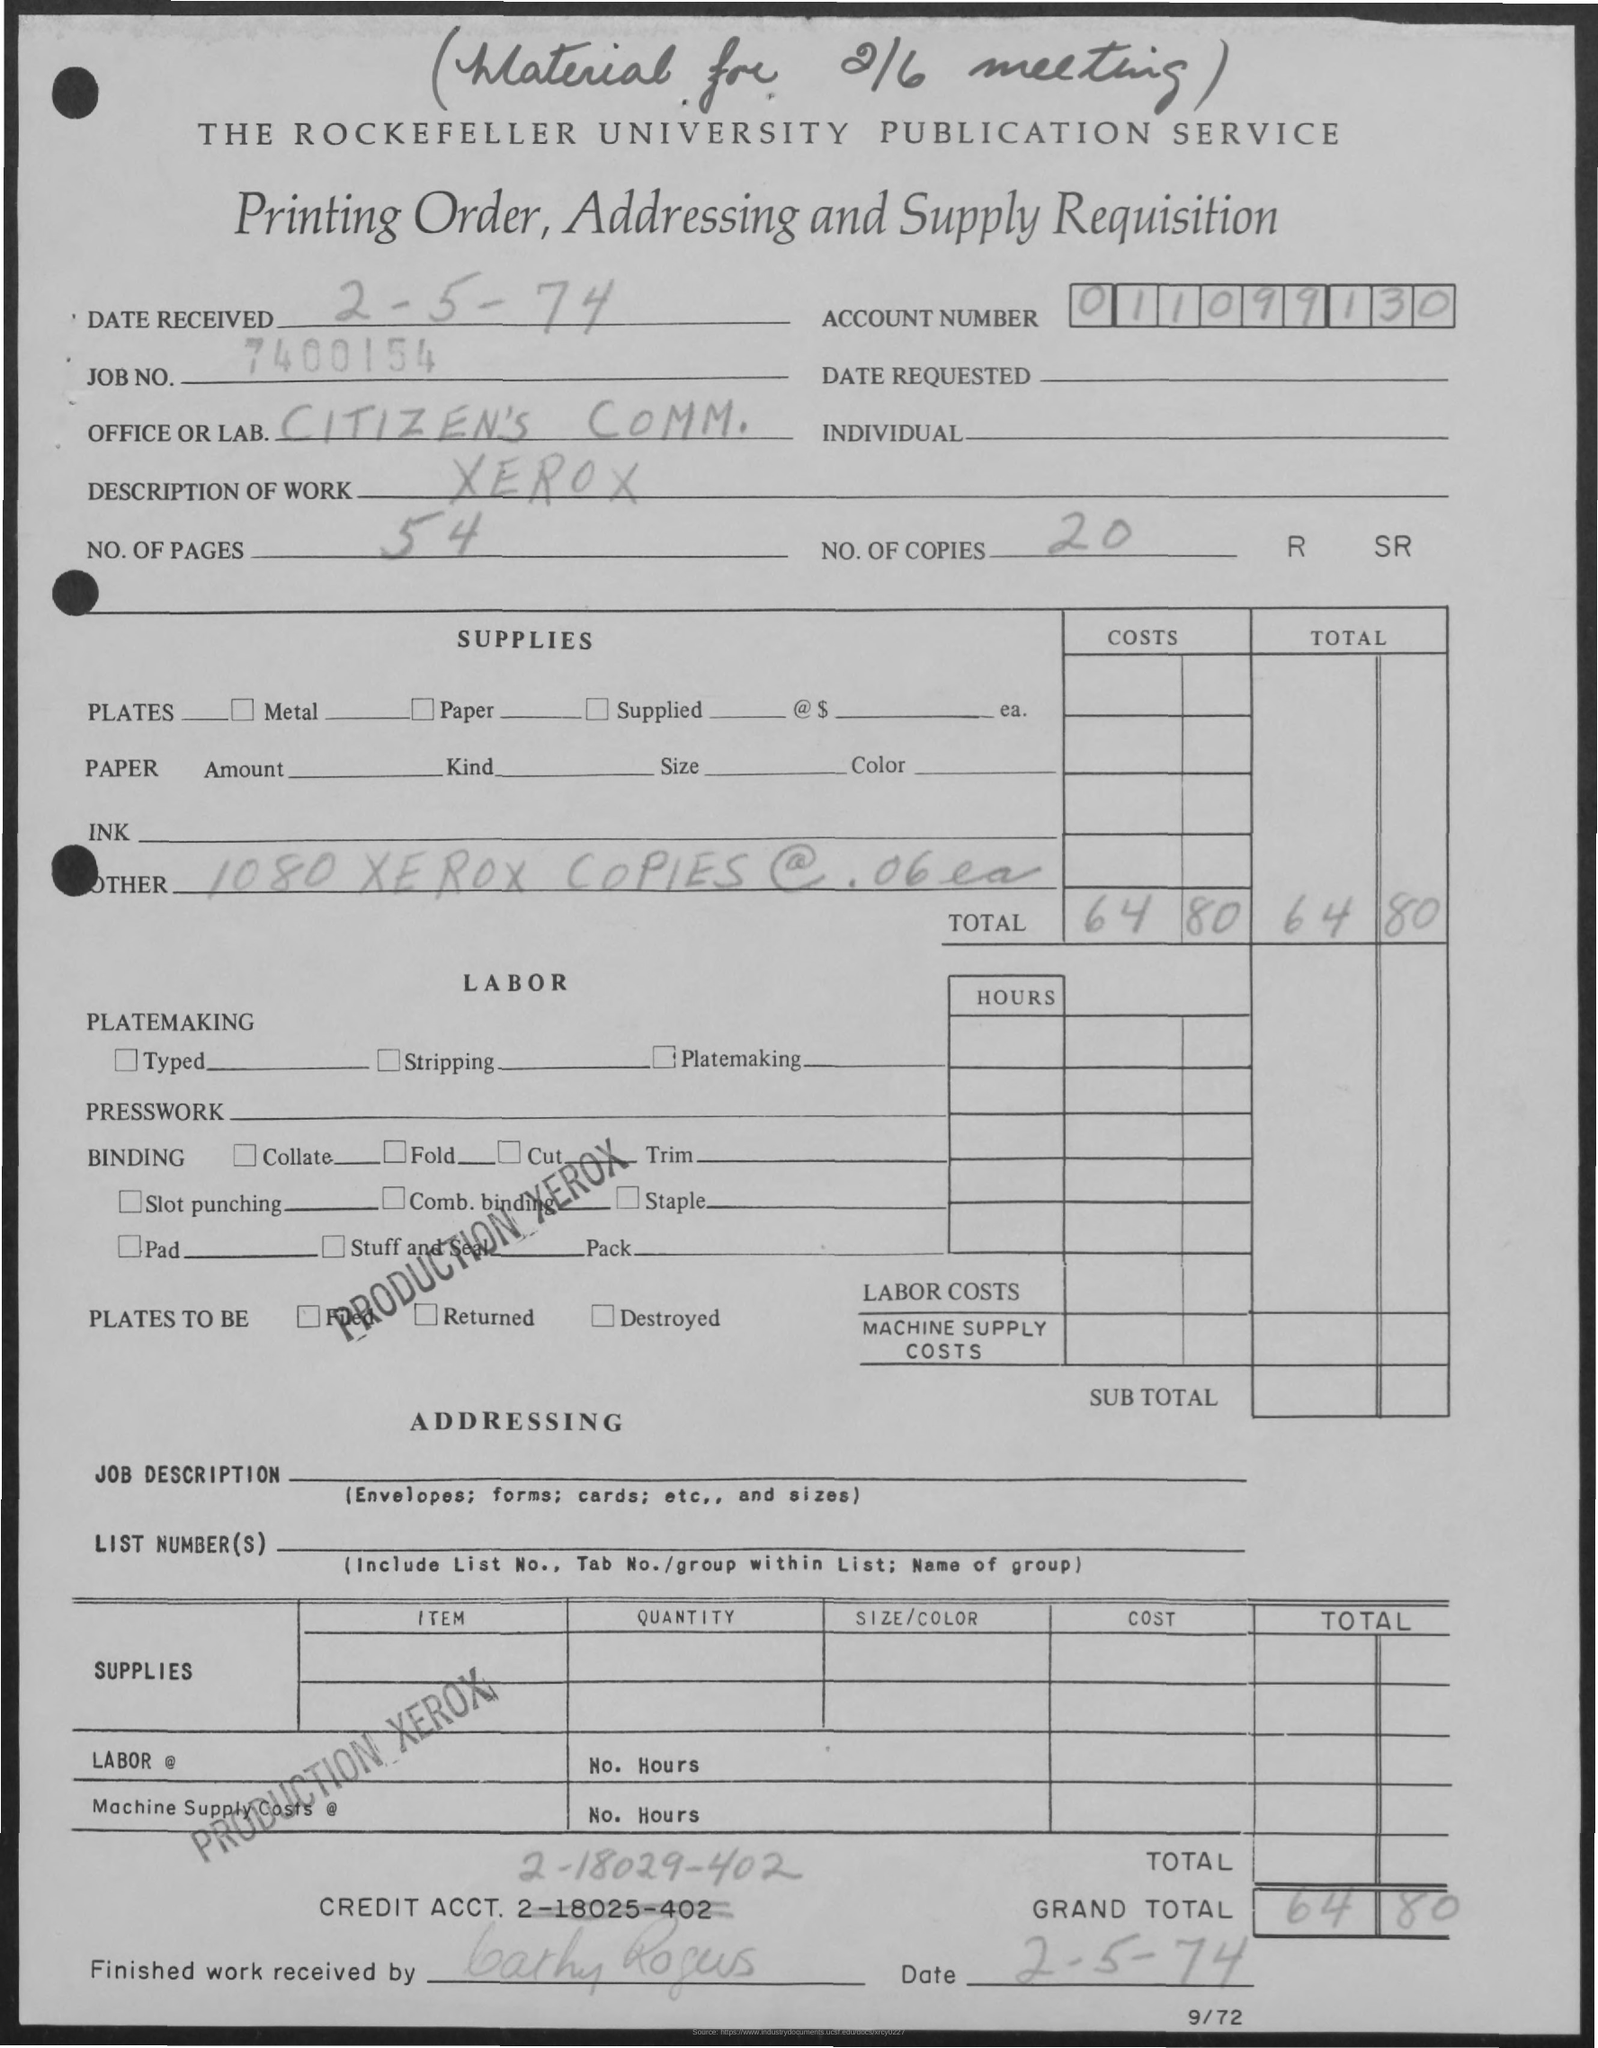What is the account number?
Ensure brevity in your answer.  011099130. What is the description of work
Provide a short and direct response. XEROX. How many no of pages ?
Keep it short and to the point. 54. How many no of copies
Your response must be concise. 20. What is the grand total
Offer a very short reply. 6480. What is the credit acct no  re written ?
Offer a terse response. 2-18029-402. 